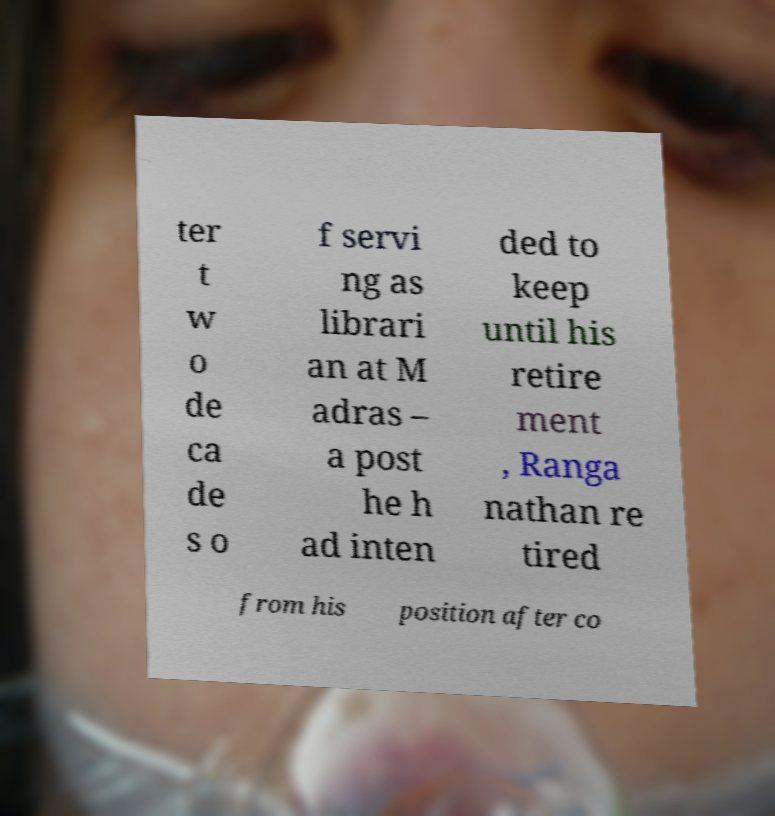Please read and relay the text visible in this image. What does it say? ter t w o de ca de s o f servi ng as librari an at M adras – a post he h ad inten ded to keep until his retire ment , Ranga nathan re tired from his position after co 